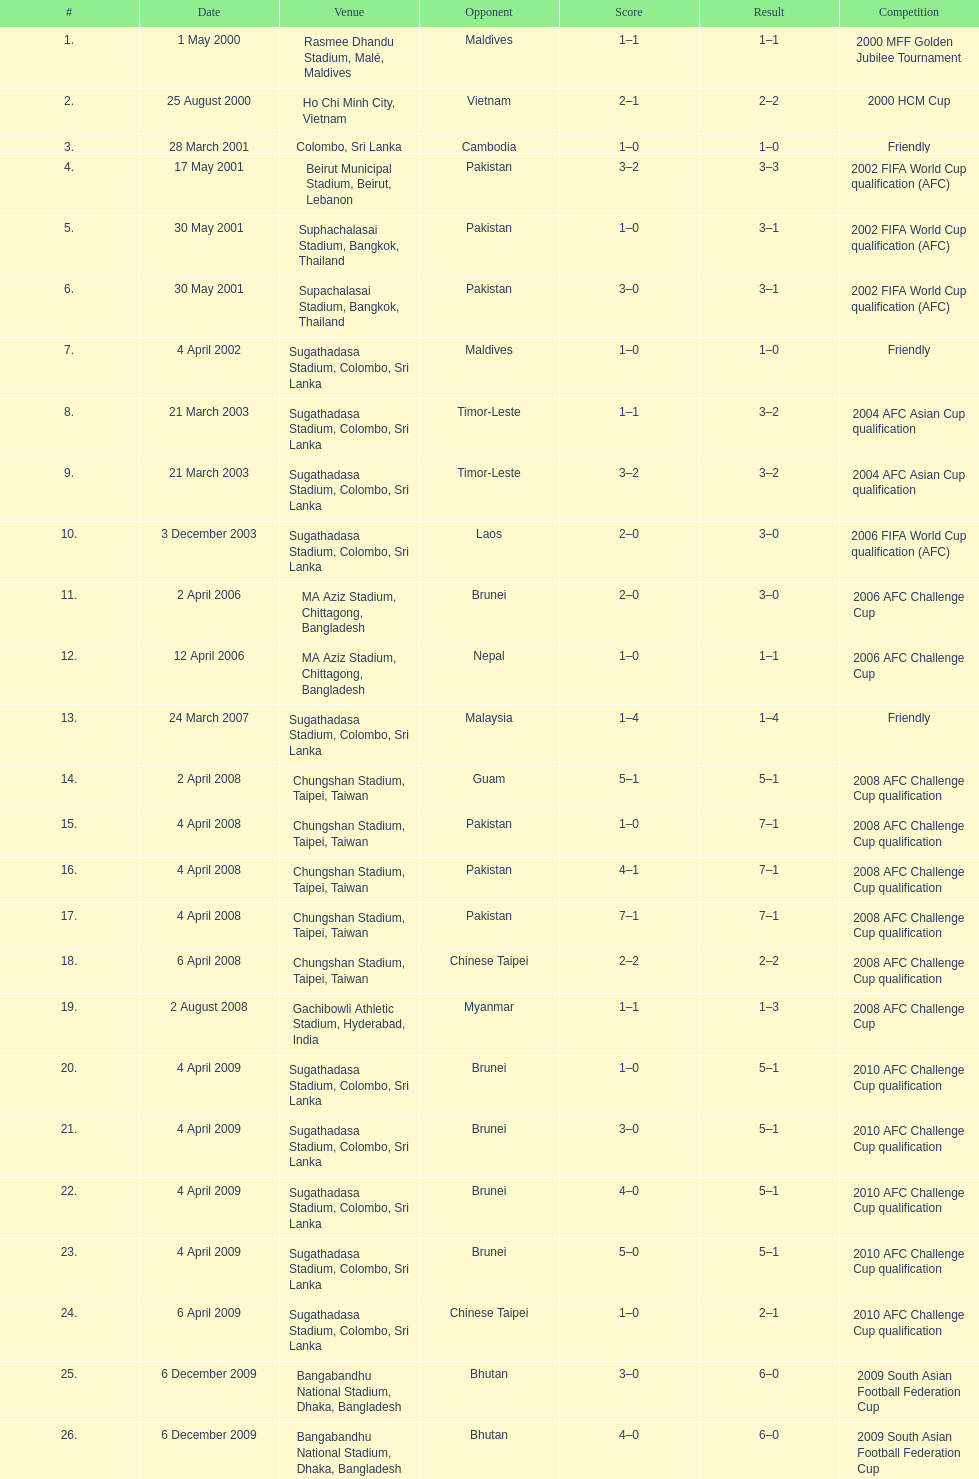What was the next venue after colombo, sri lanka on march 28? Beirut Municipal Stadium, Beirut, Lebanon. Write the full table. {'header': ['#', 'Date', 'Venue', 'Opponent', 'Score', 'Result', 'Competition'], 'rows': [['1.', '1 May 2000', 'Rasmee Dhandu Stadium, Malé, Maldives', 'Maldives', '1–1', '1–1', '2000 MFF Golden Jubilee Tournament'], ['2.', '25 August 2000', 'Ho Chi Minh City, Vietnam', 'Vietnam', '2–1', '2–2', '2000 HCM Cup'], ['3.', '28 March 2001', 'Colombo, Sri Lanka', 'Cambodia', '1–0', '1–0', 'Friendly'], ['4.', '17 May 2001', 'Beirut Municipal Stadium, Beirut, Lebanon', 'Pakistan', '3–2', '3–3', '2002 FIFA World Cup qualification (AFC)'], ['5.', '30 May 2001', 'Suphachalasai Stadium, Bangkok, Thailand', 'Pakistan', '1–0', '3–1', '2002 FIFA World Cup qualification (AFC)'], ['6.', '30 May 2001', 'Supachalasai Stadium, Bangkok, Thailand', 'Pakistan', '3–0', '3–1', '2002 FIFA World Cup qualification (AFC)'], ['7.', '4 April 2002', 'Sugathadasa Stadium, Colombo, Sri Lanka', 'Maldives', '1–0', '1–0', 'Friendly'], ['8.', '21 March 2003', 'Sugathadasa Stadium, Colombo, Sri Lanka', 'Timor-Leste', '1–1', '3–2', '2004 AFC Asian Cup qualification'], ['9.', '21 March 2003', 'Sugathadasa Stadium, Colombo, Sri Lanka', 'Timor-Leste', '3–2', '3–2', '2004 AFC Asian Cup qualification'], ['10.', '3 December 2003', 'Sugathadasa Stadium, Colombo, Sri Lanka', 'Laos', '2–0', '3–0', '2006 FIFA World Cup qualification (AFC)'], ['11.', '2 April 2006', 'MA Aziz Stadium, Chittagong, Bangladesh', 'Brunei', '2–0', '3–0', '2006 AFC Challenge Cup'], ['12.', '12 April 2006', 'MA Aziz Stadium, Chittagong, Bangladesh', 'Nepal', '1–0', '1–1', '2006 AFC Challenge Cup'], ['13.', '24 March 2007', 'Sugathadasa Stadium, Colombo, Sri Lanka', 'Malaysia', '1–4', '1–4', 'Friendly'], ['14.', '2 April 2008', 'Chungshan Stadium, Taipei, Taiwan', 'Guam', '5–1', '5–1', '2008 AFC Challenge Cup qualification'], ['15.', '4 April 2008', 'Chungshan Stadium, Taipei, Taiwan', 'Pakistan', '1–0', '7–1', '2008 AFC Challenge Cup qualification'], ['16.', '4 April 2008', 'Chungshan Stadium, Taipei, Taiwan', 'Pakistan', '4–1', '7–1', '2008 AFC Challenge Cup qualification'], ['17.', '4 April 2008', 'Chungshan Stadium, Taipei, Taiwan', 'Pakistan', '7–1', '7–1', '2008 AFC Challenge Cup qualification'], ['18.', '6 April 2008', 'Chungshan Stadium, Taipei, Taiwan', 'Chinese Taipei', '2–2', '2–2', '2008 AFC Challenge Cup qualification'], ['19.', '2 August 2008', 'Gachibowli Athletic Stadium, Hyderabad, India', 'Myanmar', '1–1', '1–3', '2008 AFC Challenge Cup'], ['20.', '4 April 2009', 'Sugathadasa Stadium, Colombo, Sri Lanka', 'Brunei', '1–0', '5–1', '2010 AFC Challenge Cup qualification'], ['21.', '4 April 2009', 'Sugathadasa Stadium, Colombo, Sri Lanka', 'Brunei', '3–0', '5–1', '2010 AFC Challenge Cup qualification'], ['22.', '4 April 2009', 'Sugathadasa Stadium, Colombo, Sri Lanka', 'Brunei', '4–0', '5–1', '2010 AFC Challenge Cup qualification'], ['23.', '4 April 2009', 'Sugathadasa Stadium, Colombo, Sri Lanka', 'Brunei', '5–0', '5–1', '2010 AFC Challenge Cup qualification'], ['24.', '6 April 2009', 'Sugathadasa Stadium, Colombo, Sri Lanka', 'Chinese Taipei', '1–0', '2–1', '2010 AFC Challenge Cup qualification'], ['25.', '6 December 2009', 'Bangabandhu National Stadium, Dhaka, Bangladesh', 'Bhutan', '3–0', '6–0', '2009 South Asian Football Federation Cup'], ['26.', '6 December 2009', 'Bangabandhu National Stadium, Dhaka, Bangladesh', 'Bhutan', '4–0', '6–0', '2009 South Asian Football Federation Cup'], ['27.', '6 December 2009', 'Bangabandhu National Stadium, Dhaka, Bangladesh', 'Bhutan', '5–0', '6–0', '2009 South Asian Football Federation Cup']]} 